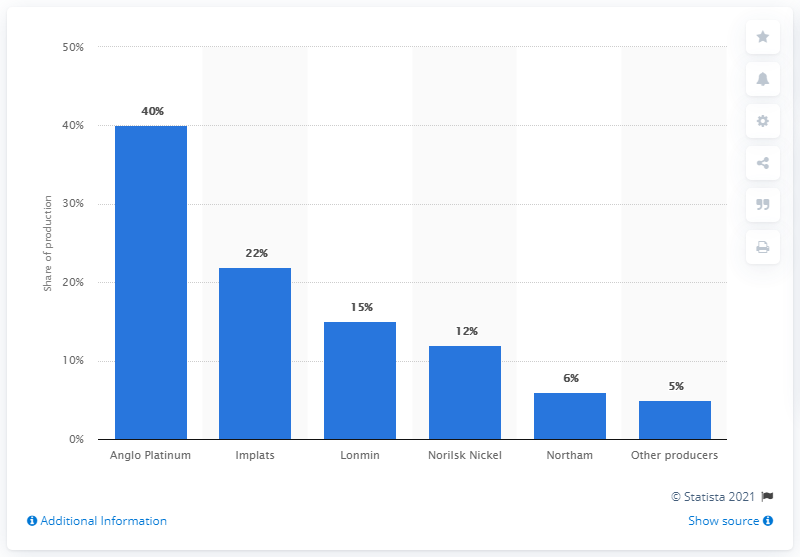Highlight a few significant elements in this photo. In 2015, Norilsk Nickel produced a significant percentage of the global supply of rhodium. In 2015, Norilsk Nickel was the third-largest producer of rhodium. 